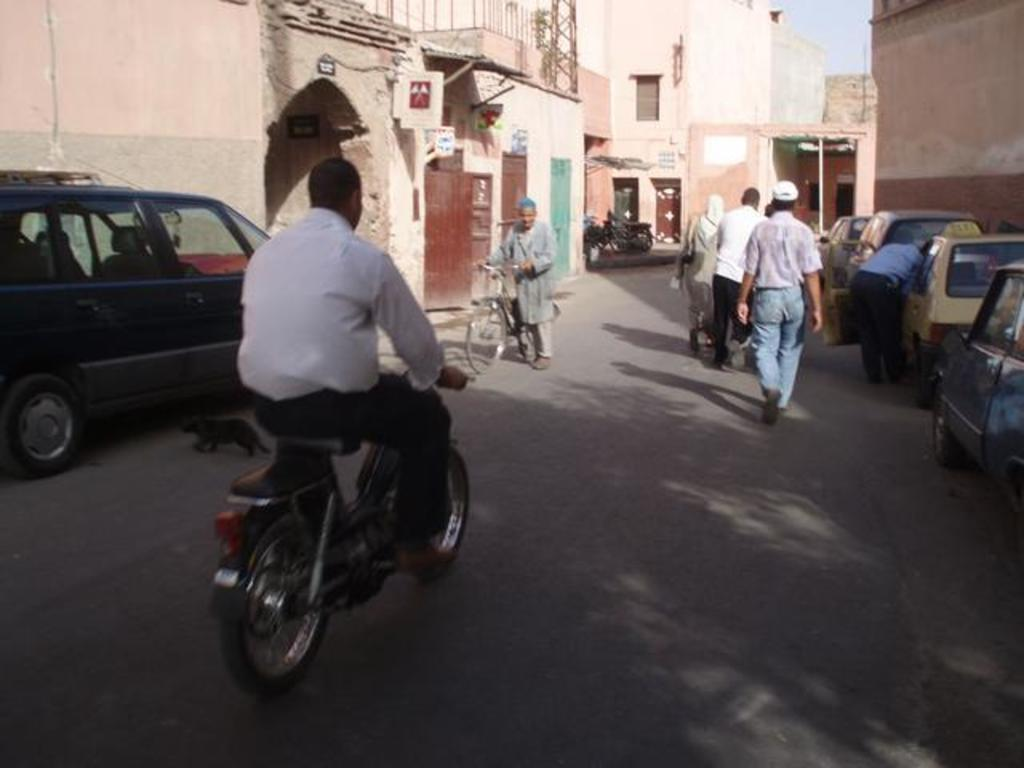What is the main subject of the image? There is a person riding a motorcycle in the image. What are some other activities happening in the image? There are people walking and vehicles on the road in the image. What can be seen in the background of the image? There is a building and the sky visible in the background of the image. What type of hair can be seen blowing in the ocean breeze in the image? There is no ocean or hair visible in the image; it features a person riding a motorcycle, people walking, vehicles on the road, a building, and the sky. 